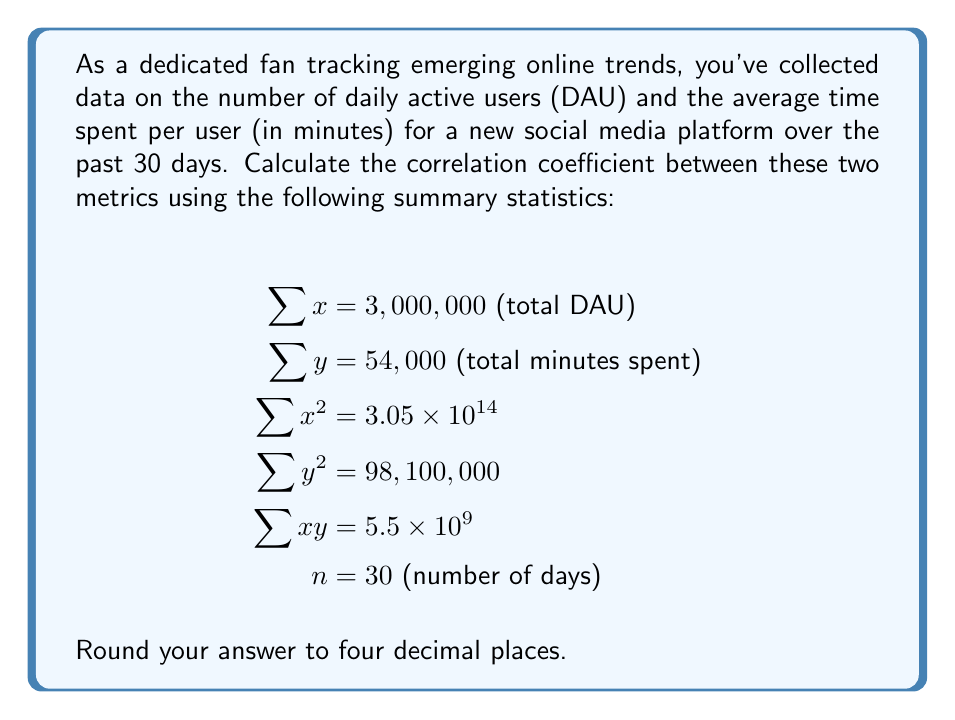Could you help me with this problem? To calculate the correlation coefficient $(r)$ between two variables $x$ and $y$, we use the formula:

$$ r = \frac{n\sum xy - (\sum x)(\sum y)}{\sqrt{[n\sum x^2 - (\sum x)^2][n\sum y^2 - (\sum y)^2]}} $$

Let's substitute the given values:

$n = 30$
$\sum x = 3,000,000$
$\sum y = 54,000$
$\sum x^2 = 3.05 \times 10^{14}$
$\sum y^2 = 98,100,000$
$\sum xy = 5.5 \times 10^9$

Now, let's calculate step by step:

1) $n\sum xy = 30 \times 5.5 \times 10^9 = 1.65 \times 10^{11}$

2) $(\sum x)(\sum y) = 3,000,000 \times 54,000 = 1.62 \times 10^{11}$

3) $n\sum x^2 = 30 \times 3.05 \times 10^{14} = 9.15 \times 10^{15}$

4) $(\sum x)^2 = (3,000,000)^2 = 9 \times 10^{12}$

5) $n\sum y^2 = 30 \times 98,100,000 = 2,943,000,000$

6) $(\sum y)^2 = (54,000)^2 = 2,916,000,000$

Now, let's substitute these values into the correlation coefficient formula:

$$ r = \frac{1.65 \times 10^{11} - 1.62 \times 10^{11}}{\sqrt{[9.15 \times 10^{15} - 9 \times 10^{12}][2,943,000,000 - 2,916,000,000]}} $$

$$ r = \frac{3 \times 10^9}{\sqrt{[9.141 \times 10^{15}][27,000,000]}} $$

$$ r = \frac{3 \times 10^9}{\sqrt{2.46807 \times 10^{23}}} $$

$$ r = \frac{3 \times 10^9}{4.96797 \times 10^{11}} $$

$$ r = 0.0060386 $$

Rounding to four decimal places, we get 0.0060.
Answer: $r = 0.0060$ 